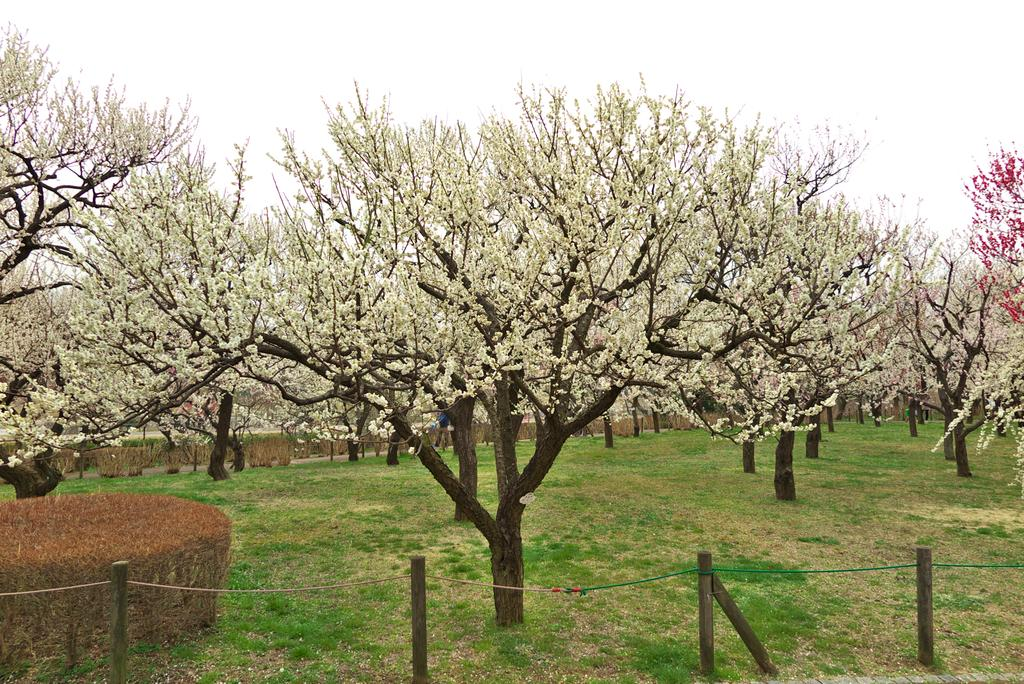What type of vegetation is present in the image? There are trees in the image. What structures can be seen in the image besides the trees? There are wooden poles in the image. What is attached to the top of the wooden poles? There is a rope at the top of the wooden poles. What is visible at the top of the image? The sky is visible at the top of the image. Can you tell me how many brothers are depicted in the image? There are no people, including brothers, present in the image. What type of stomach is visible in the image? There is no stomach present in the image; it features trees, wooden poles, and a rope. 